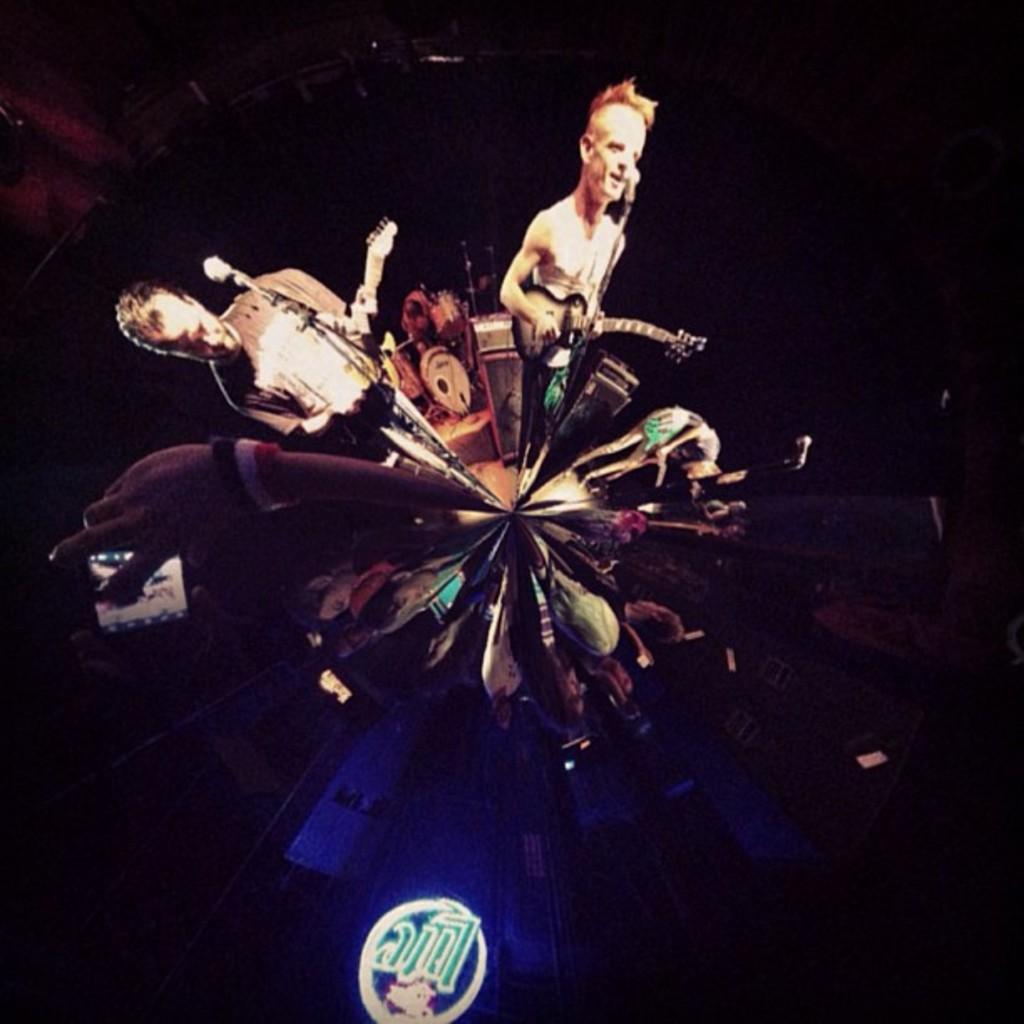How many people are in the image? There are people in the image, but the exact number is not specified. What are the people wearing? The people are wearing clothes. What are the people holding in the image? The people are holding a guitar. What other object is present in the image? There is a microphone in the image. What type of objects can be seen in the image besides the people? There are musical instruments in the image. How comfortable is the girl sitting on the chair in the image? There is no girl or chair mentioned in the image, so it is not possible to answer this question. 